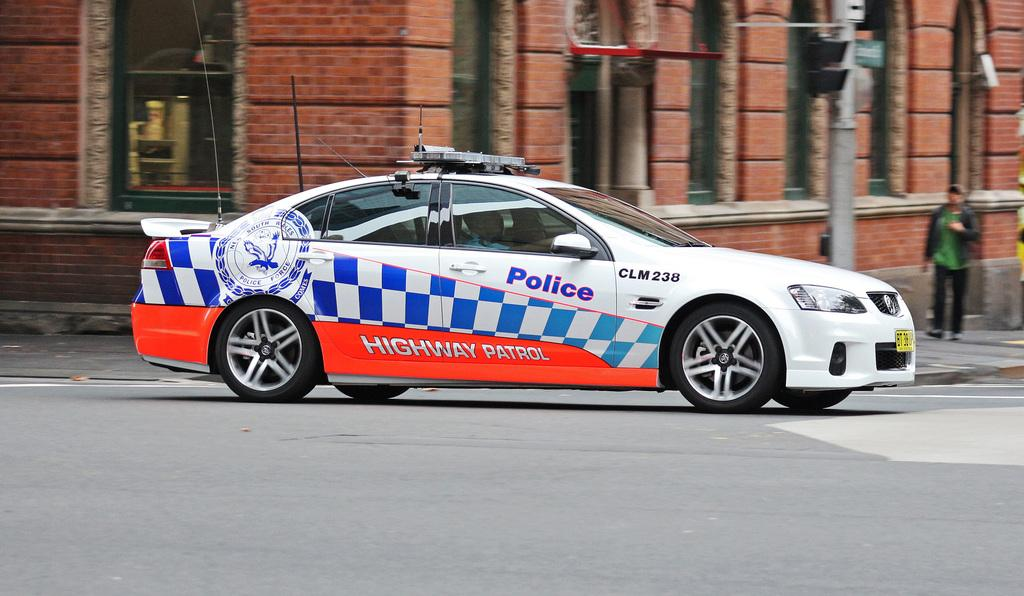What is in the foreground of the image? There is a car on the road and two persons in the foreground. What can be seen in the background of the image? There are buildings, light poles, windows, and boards visible in the background. Can you describe the time of day when the image was taken? The image was likely taken during the day, as there is no indication of darkness or artificial lighting. What type of art can be seen on the car in the image? There is no art visible on the car in the image. How many steps are required to reach the light poles in the background? There is no indication of steps or a path leading to the light poles in the image. 